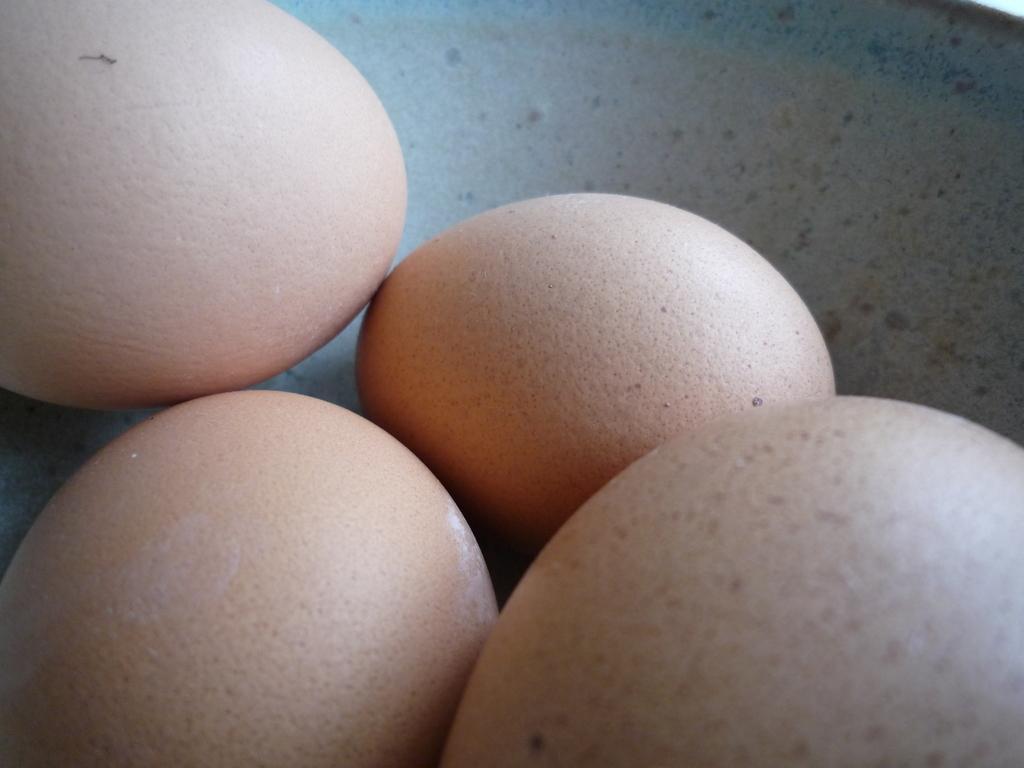Could you give a brief overview of what you see in this image? In this picture, we see four eggs. In the background, it is white in color. It might be a plate or a bowl. 